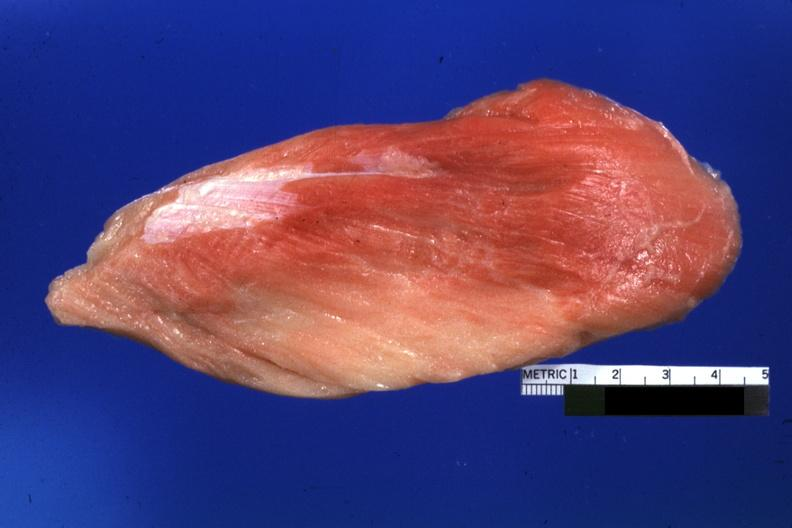how does this image show close-up of muscle?
Answer the question using a single word or phrase. With some red persisting 